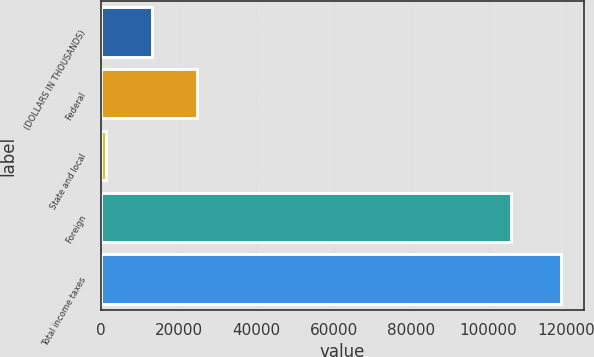Convert chart. <chart><loc_0><loc_0><loc_500><loc_500><bar_chart><fcel>(DOLLARS IN THOUSANDS)<fcel>Federal<fcel>State and local<fcel>Foreign<fcel>Total income taxes<nl><fcel>13113.3<fcel>24843.6<fcel>1383<fcel>105873<fcel>118686<nl></chart> 